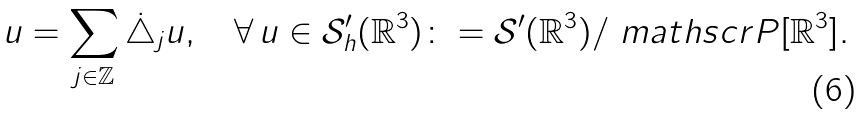<formula> <loc_0><loc_0><loc_500><loc_500>u = \sum _ { j \in \mathbb { Z } } \dot { \triangle } _ { j } u , \quad \forall \, u \in { \mathcal { S } } ^ { \prime } _ { h } ( { \mathbb { R } } ^ { 3 } ) \colon = \mathcal { S } ^ { \prime } ( \mathbb { R } ^ { 3 } ) / { \ m a t h s c r { P } } [ \mathbb { R } ^ { 3 } ] .</formula> 